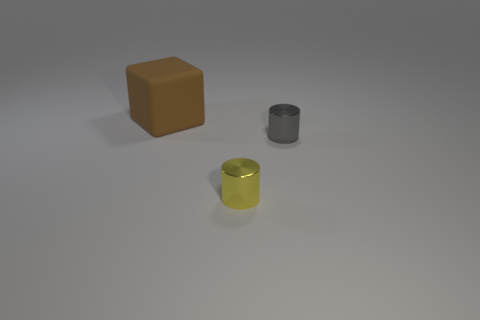Are there an equal number of tiny yellow metallic cylinders in front of the yellow metallic thing and tiny cubes?
Make the answer very short. Yes. What number of big blocks have the same material as the tiny yellow cylinder?
Your response must be concise. 0. There is a thing that is the same material as the yellow cylinder; what color is it?
Provide a short and direct response. Gray. Is the size of the brown cube the same as the metal cylinder in front of the tiny gray cylinder?
Make the answer very short. No. The big thing has what shape?
Provide a short and direct response. Cube. How many other rubber cubes are the same color as the block?
Provide a succinct answer. 0. There is another tiny thing that is the same shape as the yellow metallic object; what is its color?
Offer a terse response. Gray. What number of tiny gray shiny cylinders are to the right of the brown object that is left of the gray thing?
Make the answer very short. 1. How many blocks are large brown rubber things or small yellow objects?
Your answer should be compact. 1. Are any large brown matte objects visible?
Provide a succinct answer. Yes. 